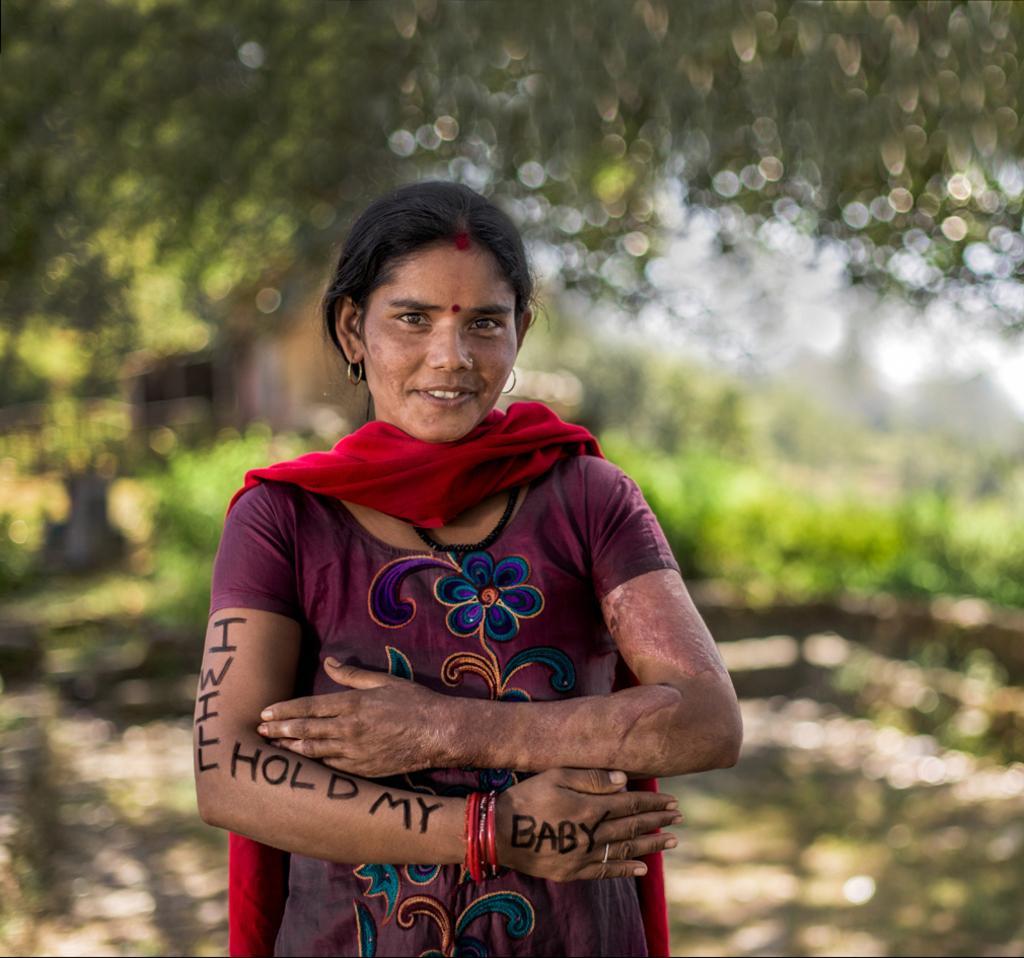Can you describe this image briefly? In the foreground of this image, there is a woman with some text on her hand. In the background, there is greenery and the image is blur. 